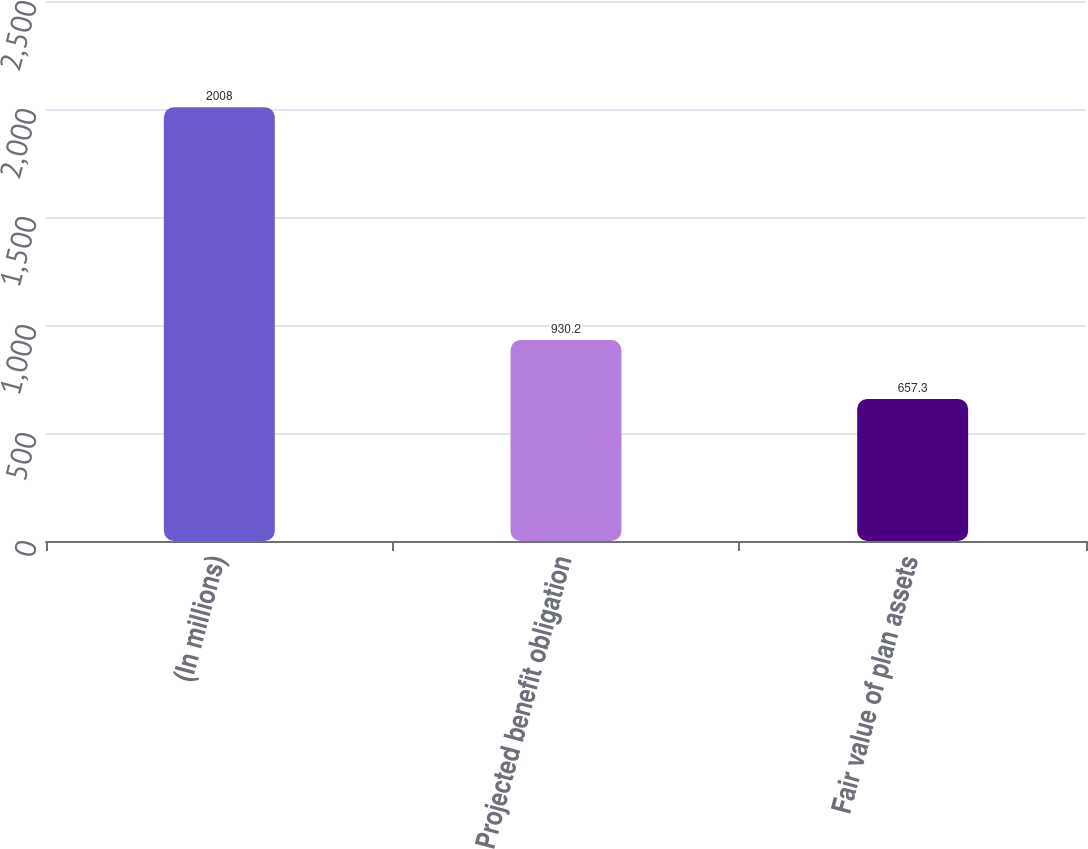Convert chart. <chart><loc_0><loc_0><loc_500><loc_500><bar_chart><fcel>(In millions)<fcel>Projected benefit obligation<fcel>Fair value of plan assets<nl><fcel>2008<fcel>930.2<fcel>657.3<nl></chart> 